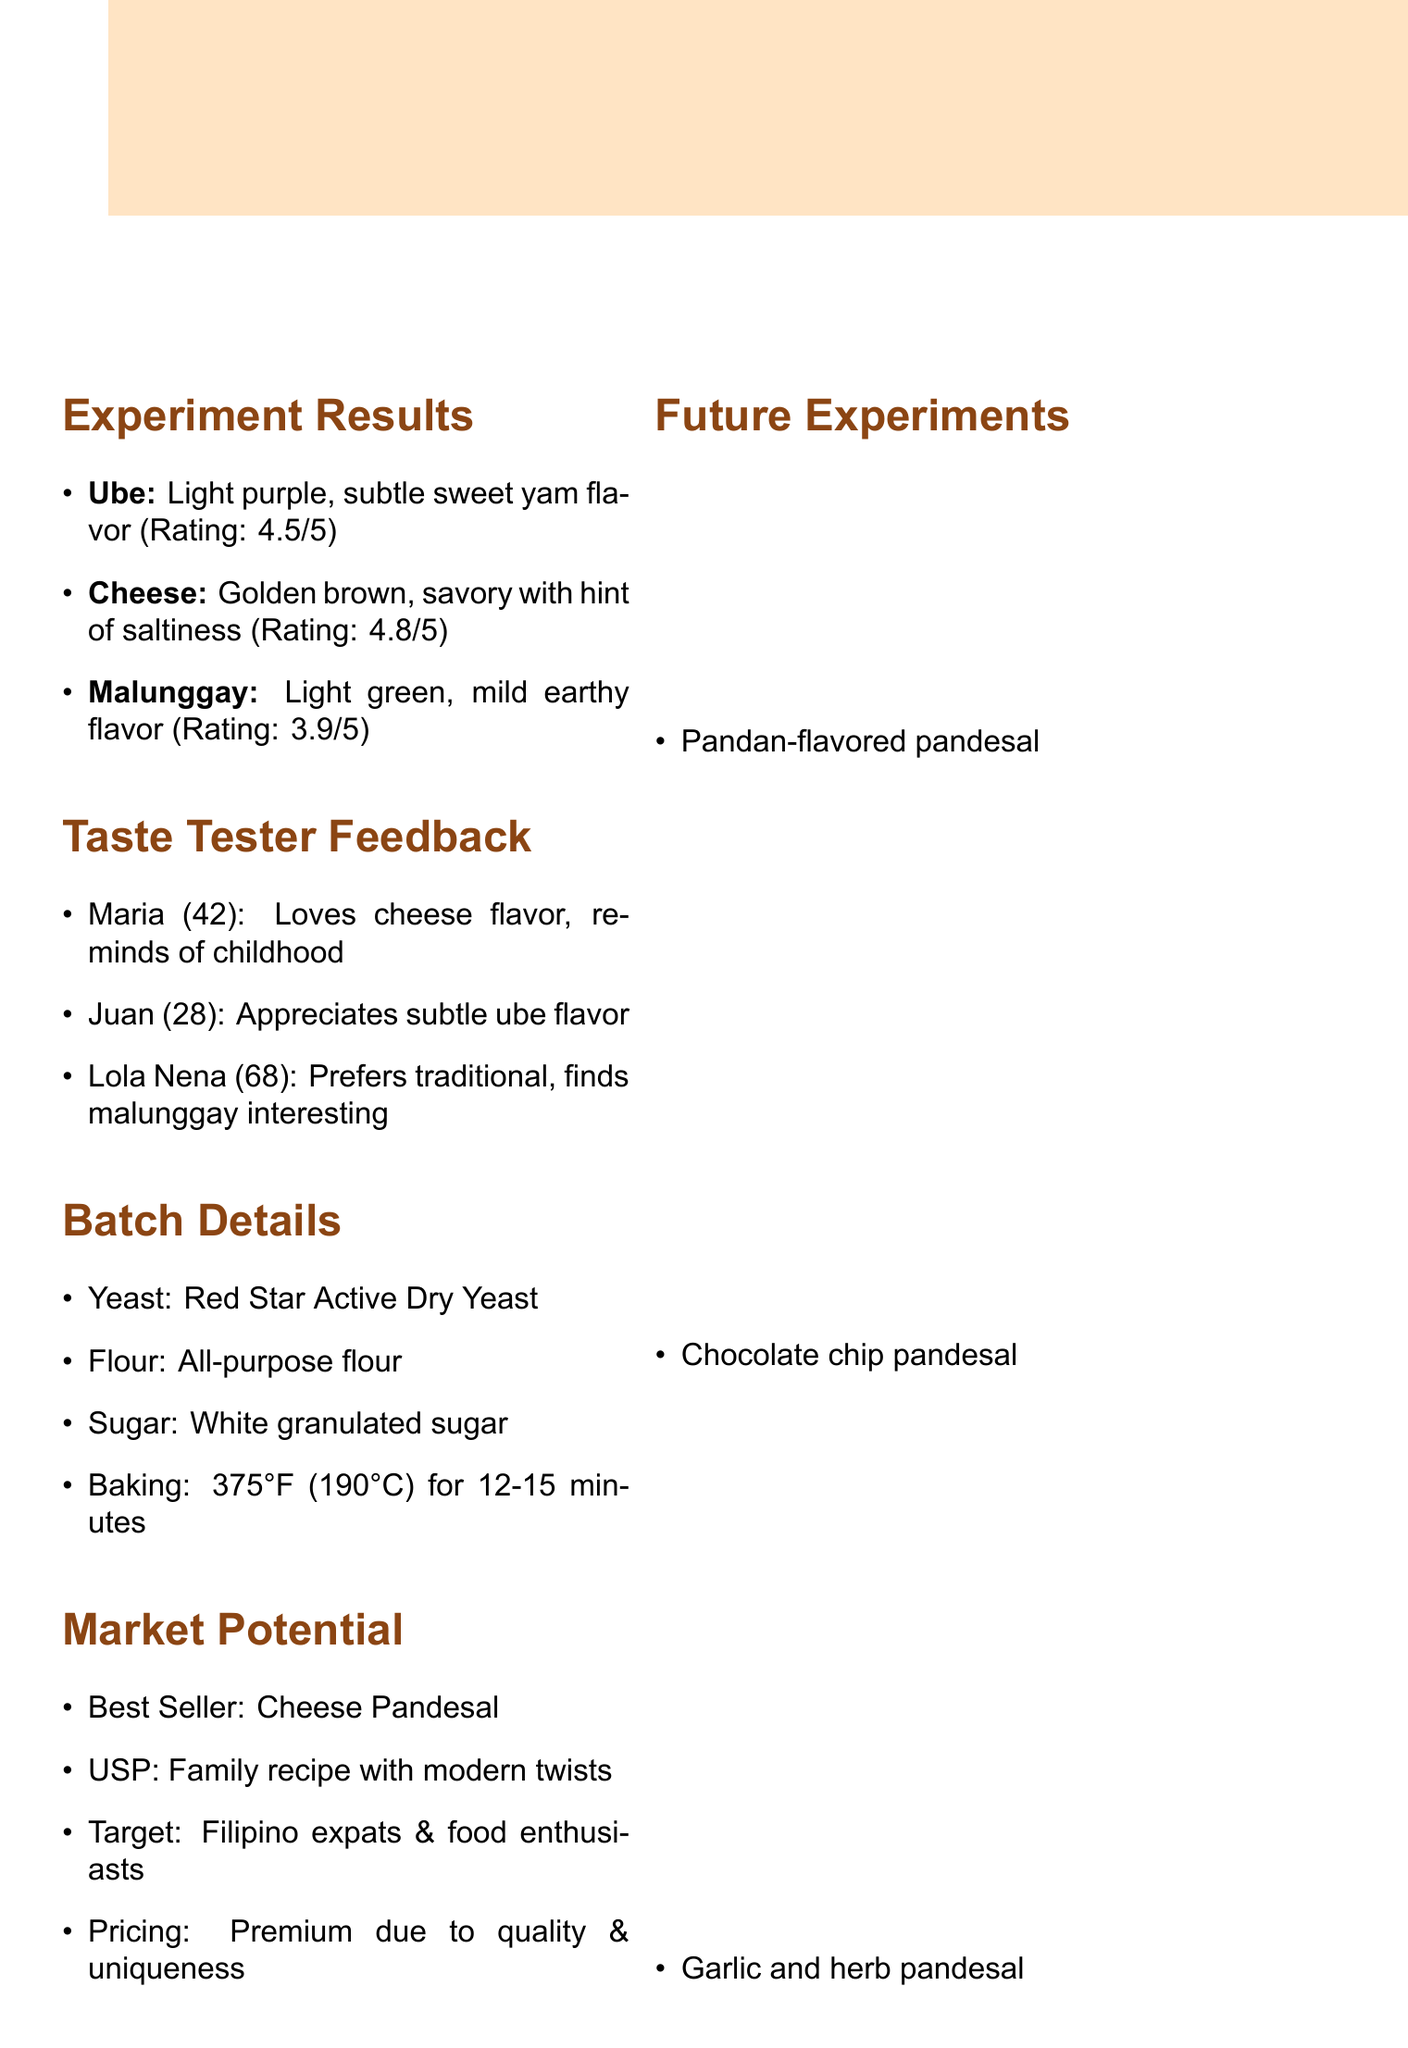What is the overall rating for Cheese pandesal? The overall rating for Cheese pandesal is provided in the Experiment Results section.
Answer: 4.8 What ingredient gives the Ube pandesal its color? The color of Ube pandesal is derived from the ingredient listed in the Experiment Results section.
Answer: Ube halaya How does the texture of Malunggay pandesal compare to traditional pandesal? The texture comparison for Malunggay pandesal is mentioned in the document's Experiment Results.
Answer: Similar to traditional pandesal Who is the oldest taste tester mentioned in the feedback? The age of each taste tester is provided in the Taste Tester Feedback section, allowing identification of the oldest.
Answer: Lola Nena What is the target customer segment for the unique selling point? The target customers for the product can be found in the Market Potential section.
Answer: Filipino expats and adventurous food lovers What baking temperature is recommended for the pandesal? The recommended baking temperature is specified in the Batch Details section of the memo.
Answer: 375°F (190°C) How many unique flavors are mentioned for future experiments? The Future Experiments section lists the flavors, allowing for a simple count.
Answer: 3 